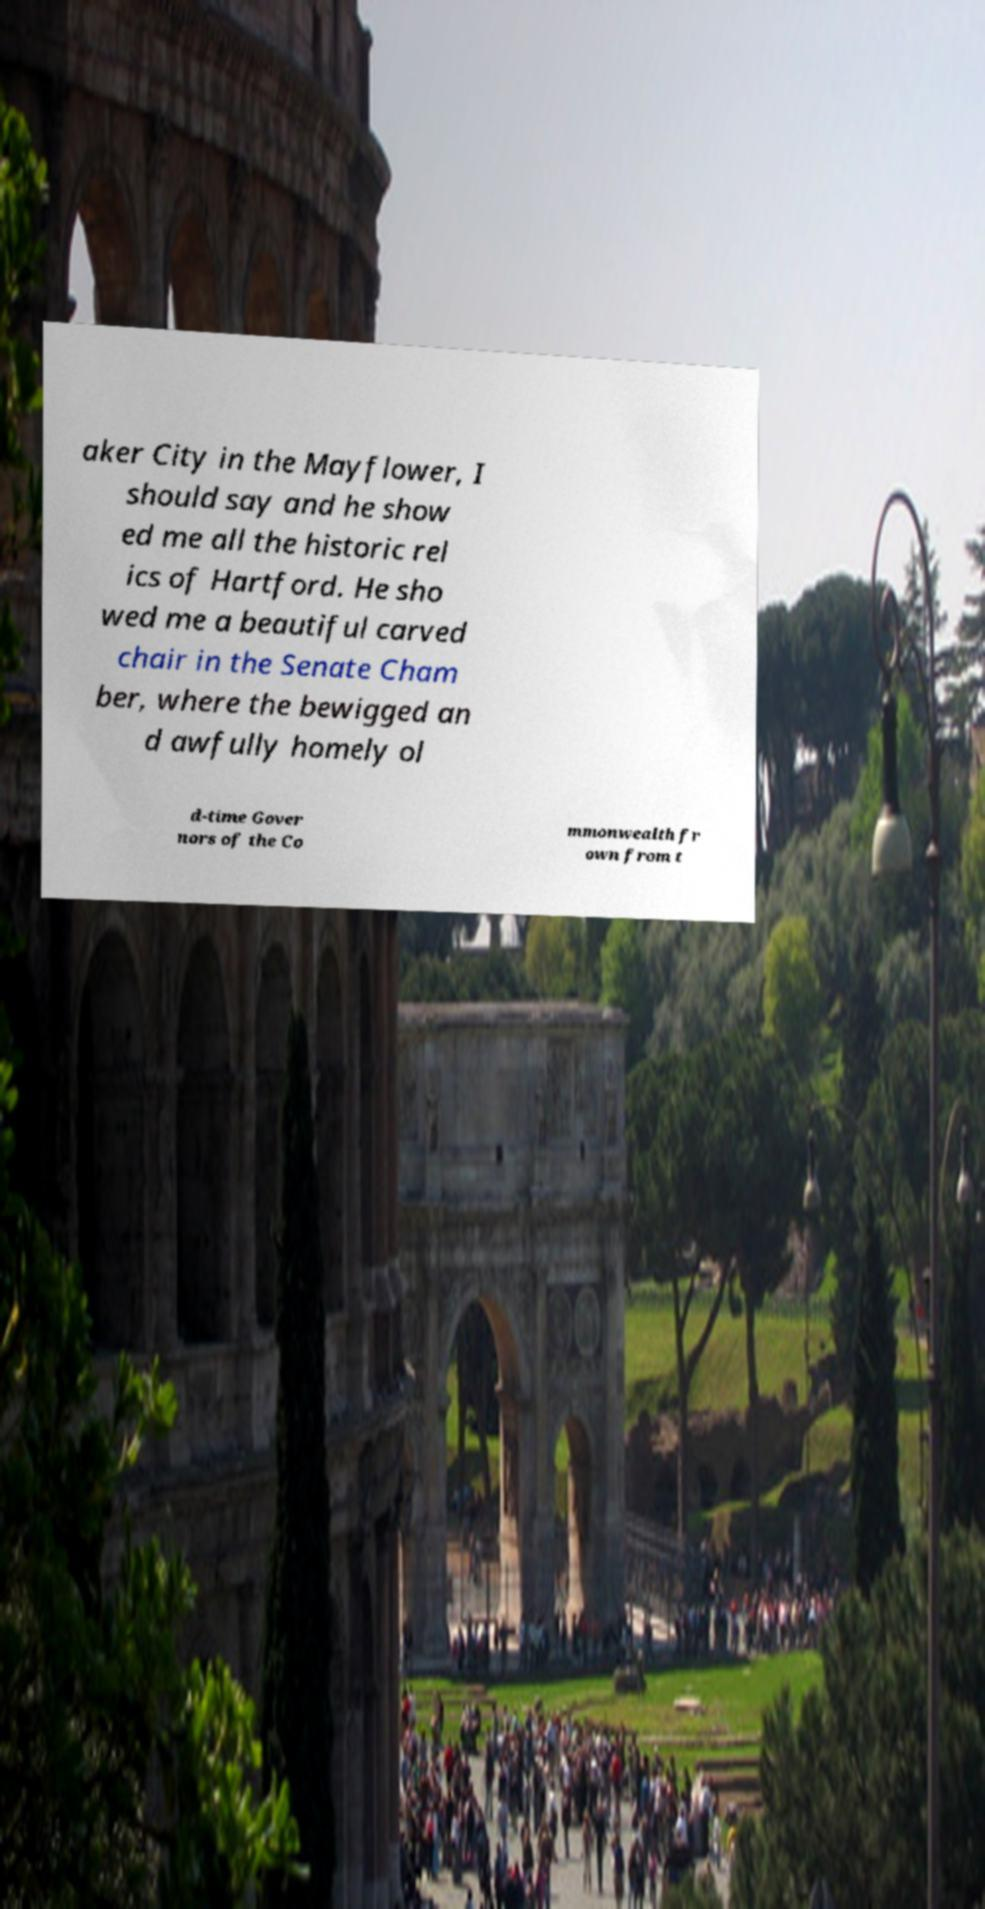What messages or text are displayed in this image? I need them in a readable, typed format. aker City in the Mayflower, I should say and he show ed me all the historic rel ics of Hartford. He sho wed me a beautiful carved chair in the Senate Cham ber, where the bewigged an d awfully homely ol d-time Gover nors of the Co mmonwealth fr own from t 